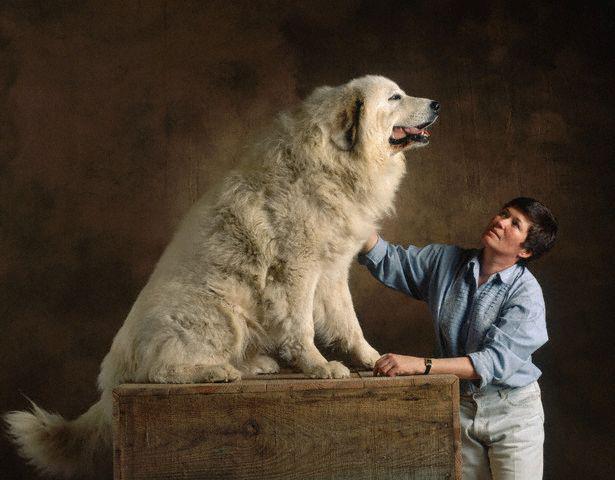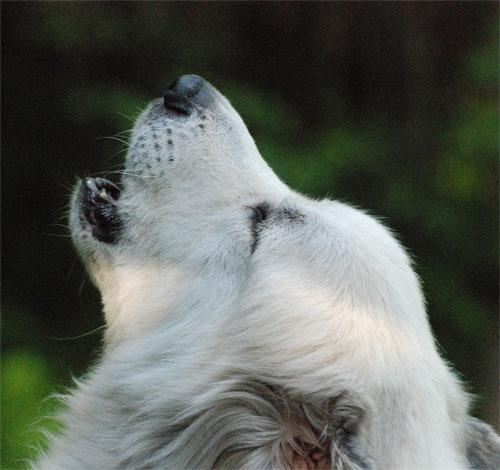The first image is the image on the left, the second image is the image on the right. Evaluate the accuracy of this statement regarding the images: "The images together contain no more than two dogs.". Is it true? Answer yes or no. Yes. The first image is the image on the left, the second image is the image on the right. Analyze the images presented: Is the assertion "There are at most two dogs." valid? Answer yes or no. Yes. 